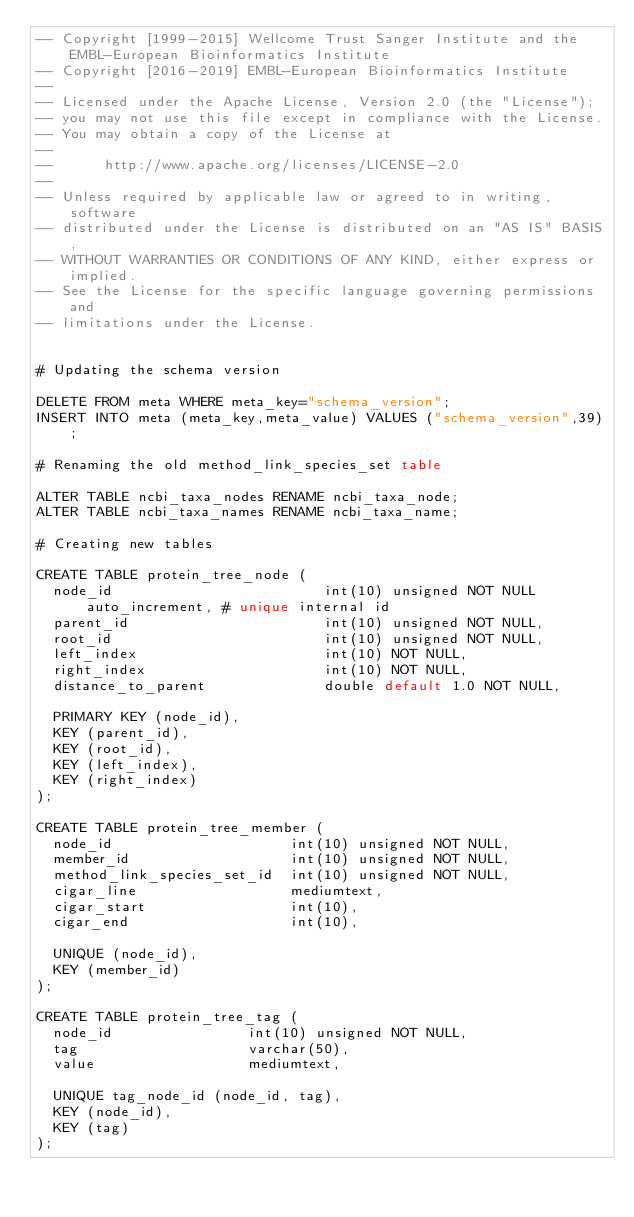Convert code to text. <code><loc_0><loc_0><loc_500><loc_500><_SQL_>-- Copyright [1999-2015] Wellcome Trust Sanger Institute and the EMBL-European Bioinformatics Institute
-- Copyright [2016-2019] EMBL-European Bioinformatics Institute
-- 
-- Licensed under the Apache License, Version 2.0 (the "License");
-- you may not use this file except in compliance with the License.
-- You may obtain a copy of the License at
-- 
--      http://www.apache.org/licenses/LICENSE-2.0
-- 
-- Unless required by applicable law or agreed to in writing, software
-- distributed under the License is distributed on an "AS IS" BASIS,
-- WITHOUT WARRANTIES OR CONDITIONS OF ANY KIND, either express or implied.
-- See the License for the specific language governing permissions and
-- limitations under the License.


# Updating the schema version

DELETE FROM meta WHERE meta_key="schema_version";
INSERT INTO meta (meta_key,meta_value) VALUES ("schema_version",39);

# Renaming the old method_link_species_set table

ALTER TABLE ncbi_taxa_nodes RENAME ncbi_taxa_node;
ALTER TABLE ncbi_taxa_names RENAME ncbi_taxa_name;

# Creating new tables

CREATE TABLE protein_tree_node (
  node_id                         int(10) unsigned NOT NULL auto_increment, # unique internal id
  parent_id                       int(10) unsigned NOT NULL,
  root_id                         int(10) unsigned NOT NULL,
  left_index                      int(10) NOT NULL,
  right_index                     int(10) NOT NULL,
  distance_to_parent              double default 1.0 NOT NULL,
  
  PRIMARY KEY (node_id),
  KEY (parent_id),
  KEY (root_id),
  KEY (left_index),
  KEY (right_index)
);

CREATE TABLE protein_tree_member (
  node_id                     int(10) unsigned NOT NULL,
  member_id                   int(10) unsigned NOT NULL, 
  method_link_species_set_id  int(10) unsigned NOT NULL,
  cigar_line                  mediumtext,
  cigar_start                 int(10),
  cigar_end                   int(10),

  UNIQUE (node_id),
  KEY (member_id)
);

CREATE TABLE protein_tree_tag (
  node_id                int(10) unsigned NOT NULL,
  tag                    varchar(50),
  value                  mediumtext,

  UNIQUE tag_node_id (node_id, tag),
  KEY (node_id),
  KEY (tag)
);

</code> 